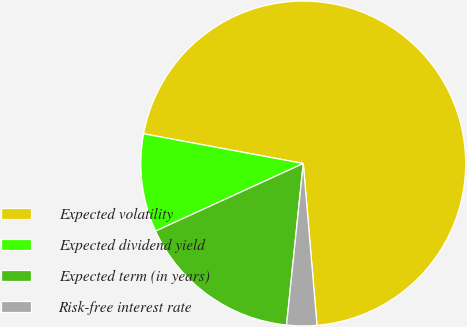<chart> <loc_0><loc_0><loc_500><loc_500><pie_chart><fcel>Expected volatility<fcel>Expected dividend yield<fcel>Expected term (in years)<fcel>Risk-free interest rate<nl><fcel>70.73%<fcel>9.76%<fcel>16.53%<fcel>2.99%<nl></chart> 